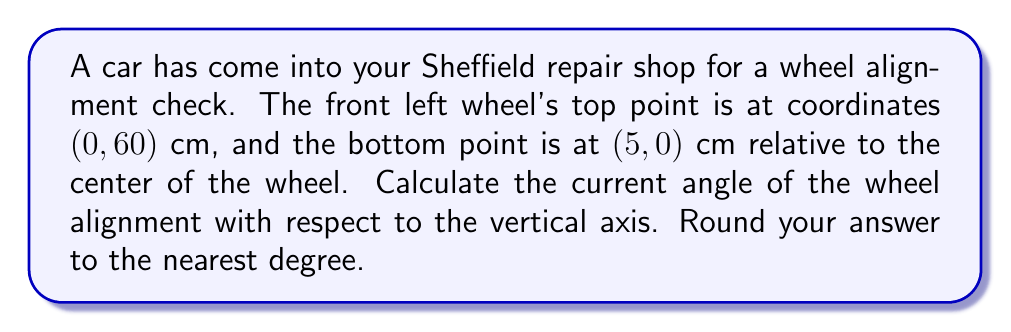Teach me how to tackle this problem. To solve this problem, we'll use coordinate geometry and trigonometry. Let's break it down step-by-step:

1) First, let's visualize the problem:

[asy]
unitsize(1cm);
draw((0,0)--(5,0)--(5,60)--(0,60)--cycle);
draw((0,0)--(5,60), dashed);
label("(0, 60)", (0,60), W);
label("(5, 0)", (5,0), E);
label("θ", (0.5,0.5), NW);
[/asy]

2) We need to find the angle θ between the line connecting the two points and the vertical axis.

3) To do this, we can use the arctangent function. The tangent of the angle is the ratio of the horizontal distance to the vertical distance.

4) Horizontal distance: 5 cm
   Vertical distance: 60 cm

5) The tangent of the angle is:

   $$\tan(\theta) = \frac{\text{opposite}}{\text{adjacent}} = \frac{5}{60} = \frac{1}{12}$$

6) To find θ, we take the arctangent (inverse tangent) of this ratio:

   $$\theta = \arctan(\frac{1}{12})$$

7) Using a calculator or computer:

   $$\theta \approx 4.7636 \text{ degrees}$$

8) Rounding to the nearest degree:

   $$\theta \approx 5 \text{ degrees}$$

This means the wheel is currently misaligned by about 5 degrees from the vertical.
Answer: $5^\circ$ (5 degrees) 